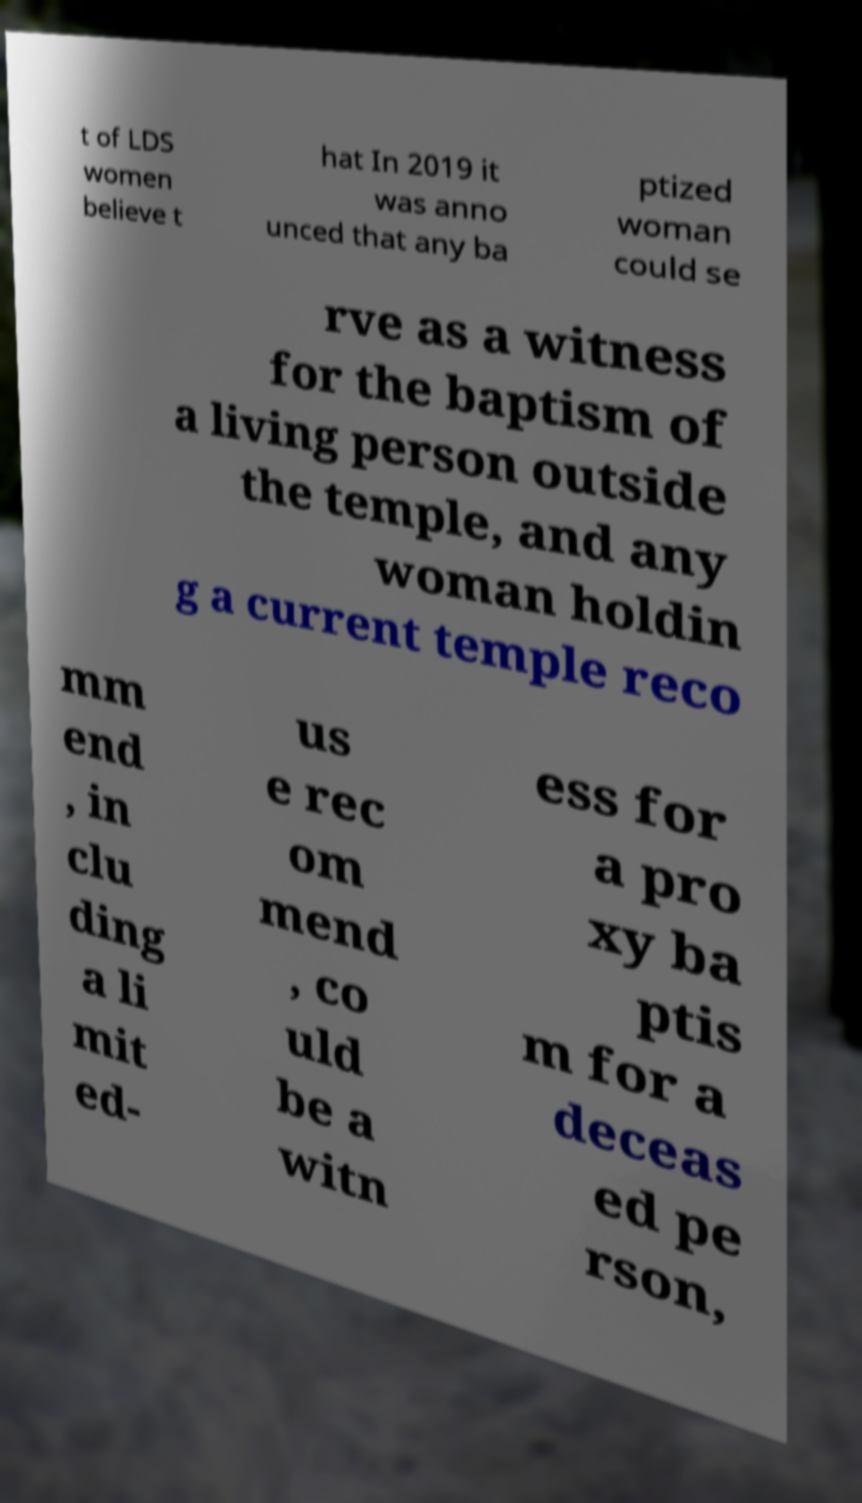I need the written content from this picture converted into text. Can you do that? t of LDS women believe t hat In 2019 it was anno unced that any ba ptized woman could se rve as a witness for the baptism of a living person outside the temple, and any woman holdin g a current temple reco mm end , in clu ding a li mit ed- us e rec om mend , co uld be a witn ess for a pro xy ba ptis m for a deceas ed pe rson, 